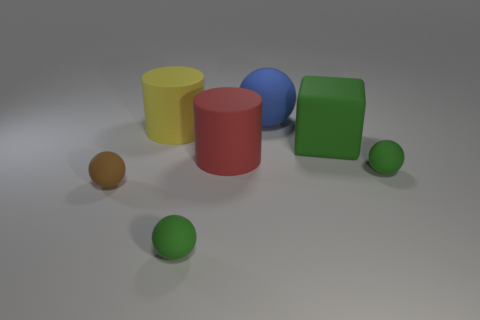Subtract 1 balls. How many balls are left? 3 Add 1 red objects. How many objects exist? 8 Subtract all spheres. How many objects are left? 3 Subtract all tiny green metal objects. Subtract all large green matte cubes. How many objects are left? 6 Add 1 small green matte objects. How many small green matte objects are left? 3 Add 5 large blue matte balls. How many large blue matte balls exist? 6 Subtract 0 gray spheres. How many objects are left? 7 